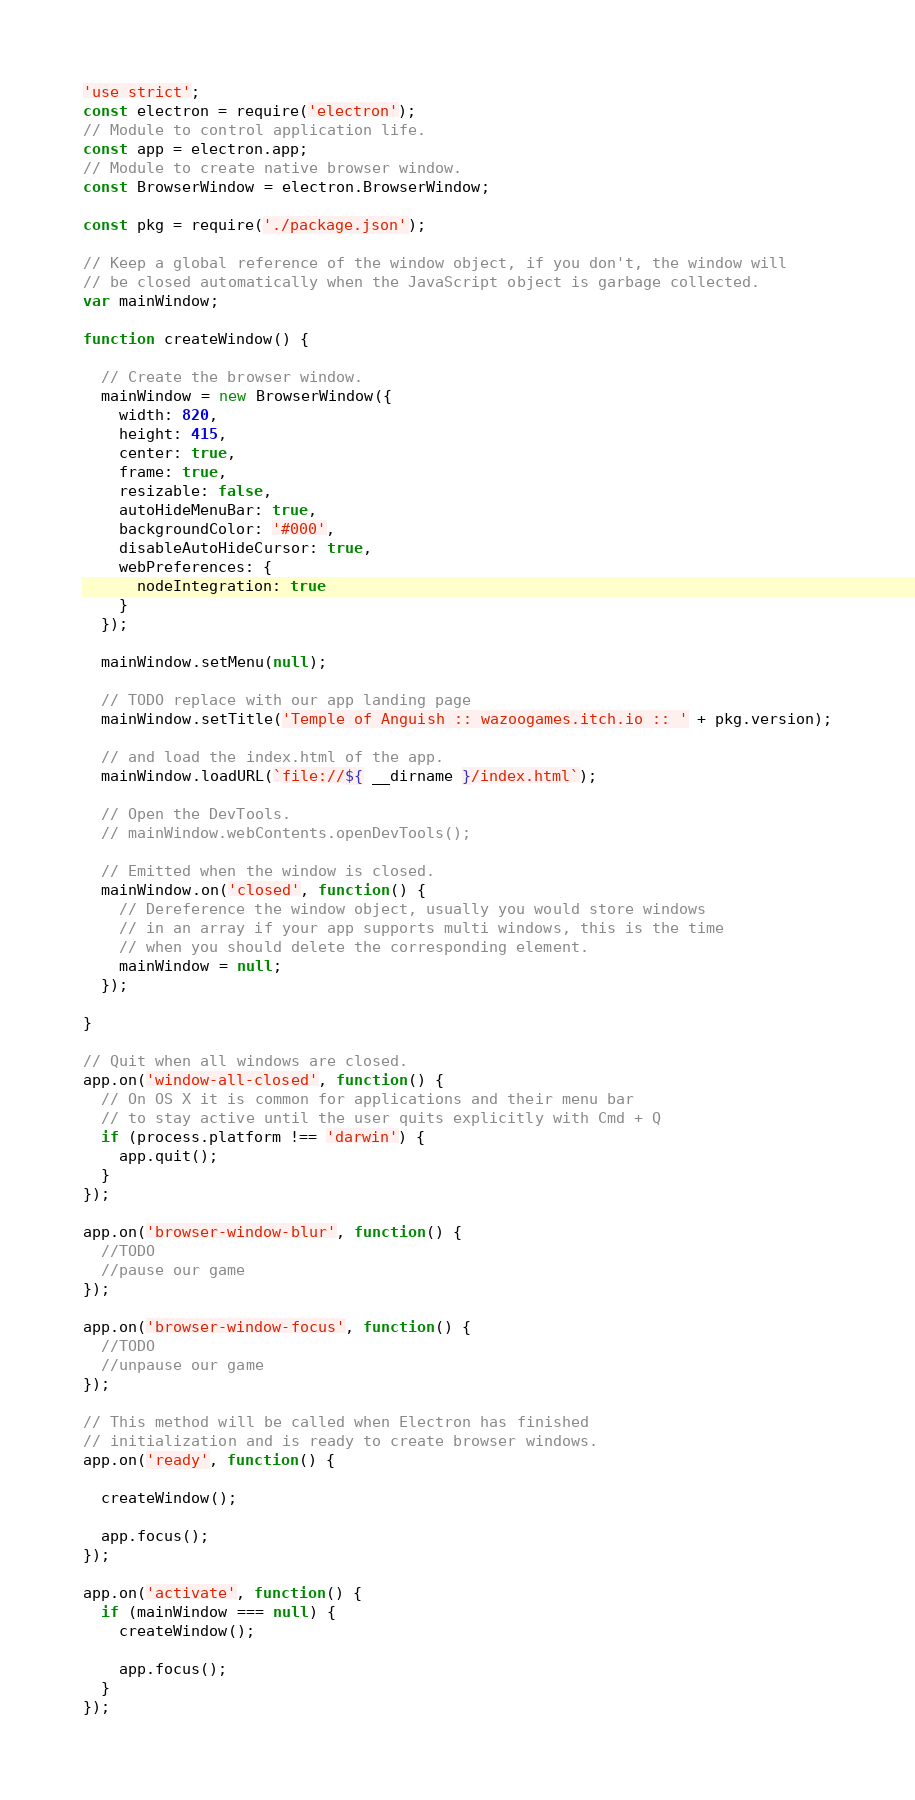Convert code to text. <code><loc_0><loc_0><loc_500><loc_500><_JavaScript_>'use strict';
const electron = require('electron');
// Module to control application life.
const app = electron.app;
// Module to create native browser window.
const BrowserWindow = electron.BrowserWindow;

const pkg = require('./package.json');

// Keep a global reference of the window object, if you don't, the window will
// be closed automatically when the JavaScript object is garbage collected.
var mainWindow;

function createWindow() {

  // Create the browser window.
  mainWindow = new BrowserWindow({
    width: 820,
    height: 415,
    center: true,
    frame: true,
    resizable: false,
    autoHideMenuBar: true,
    backgroundColor: '#000',
    disableAutoHideCursor: true,
    webPreferences: {
      nodeIntegration: true
    }
  });

  mainWindow.setMenu(null);

  // TODO replace with our app landing page
  mainWindow.setTitle('Temple of Anguish :: wazoogames.itch.io :: ' + pkg.version);

  // and load the index.html of the app.
  mainWindow.loadURL(`file://${ __dirname }/index.html`);

  // Open the DevTools.
  // mainWindow.webContents.openDevTools();

  // Emitted when the window is closed.
  mainWindow.on('closed', function() {
    // Dereference the window object, usually you would store windows
    // in an array if your app supports multi windows, this is the time
    // when you should delete the corresponding element.
    mainWindow = null;
  });

}

// Quit when all windows are closed.
app.on('window-all-closed', function() {
  // On OS X it is common for applications and their menu bar
  // to stay active until the user quits explicitly with Cmd + Q
  if (process.platform !== 'darwin') {
    app.quit();
  }
});

app.on('browser-window-blur', function() {
  //TODO
  //pause our game
});

app.on('browser-window-focus', function() {
  //TODO
  //unpause our game
});

// This method will be called when Electron has finished
// initialization and is ready to create browser windows.
app.on('ready', function() {

  createWindow();

  app.focus();
});

app.on('activate', function() {
  if (mainWindow === null) {
    createWindow();

    app.focus();
  }
});
</code> 